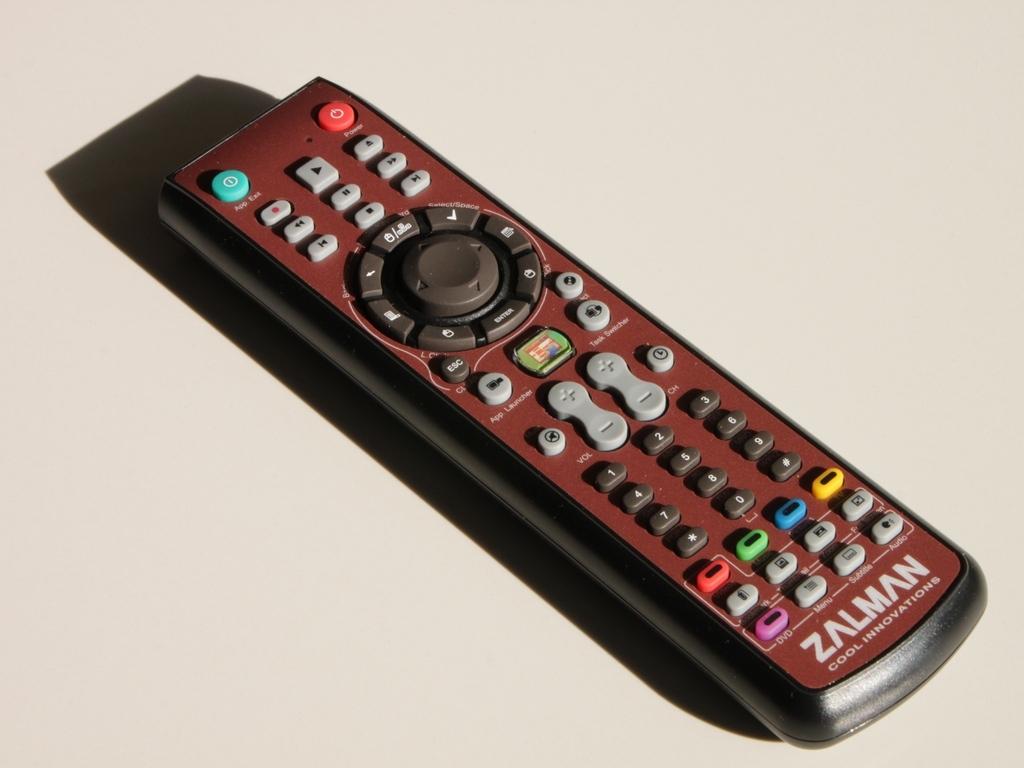Is zalman a general tech company?
Provide a short and direct response. Unanswerable. 